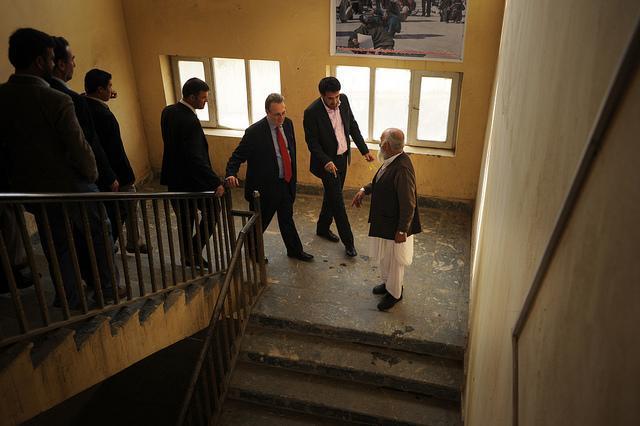How many people are wearing white trousers?
Give a very brief answer. 1. How many pictures are in the background?
Give a very brief answer. 1. How many people are in the photo?
Give a very brief answer. 7. 